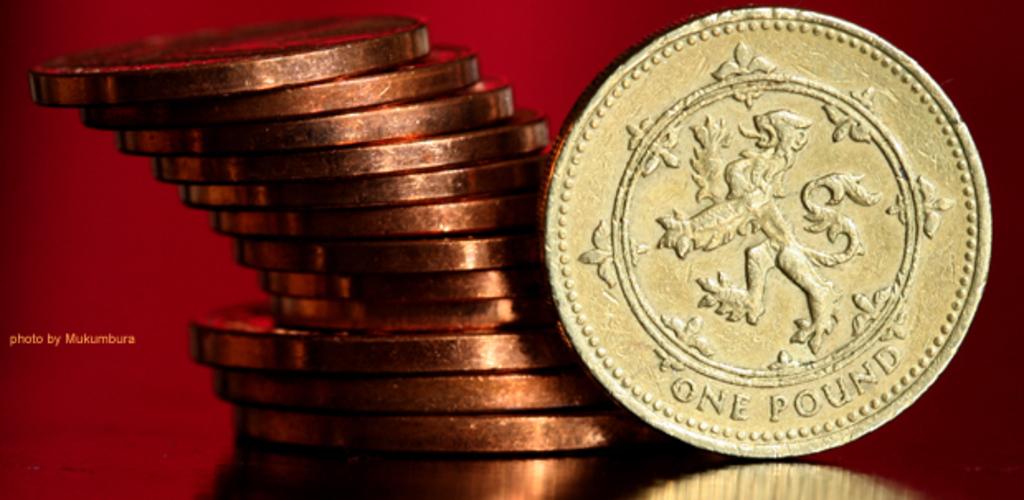How much is that coin worth?
Make the answer very short. One pound. How many pounds is this?
Make the answer very short. One. 